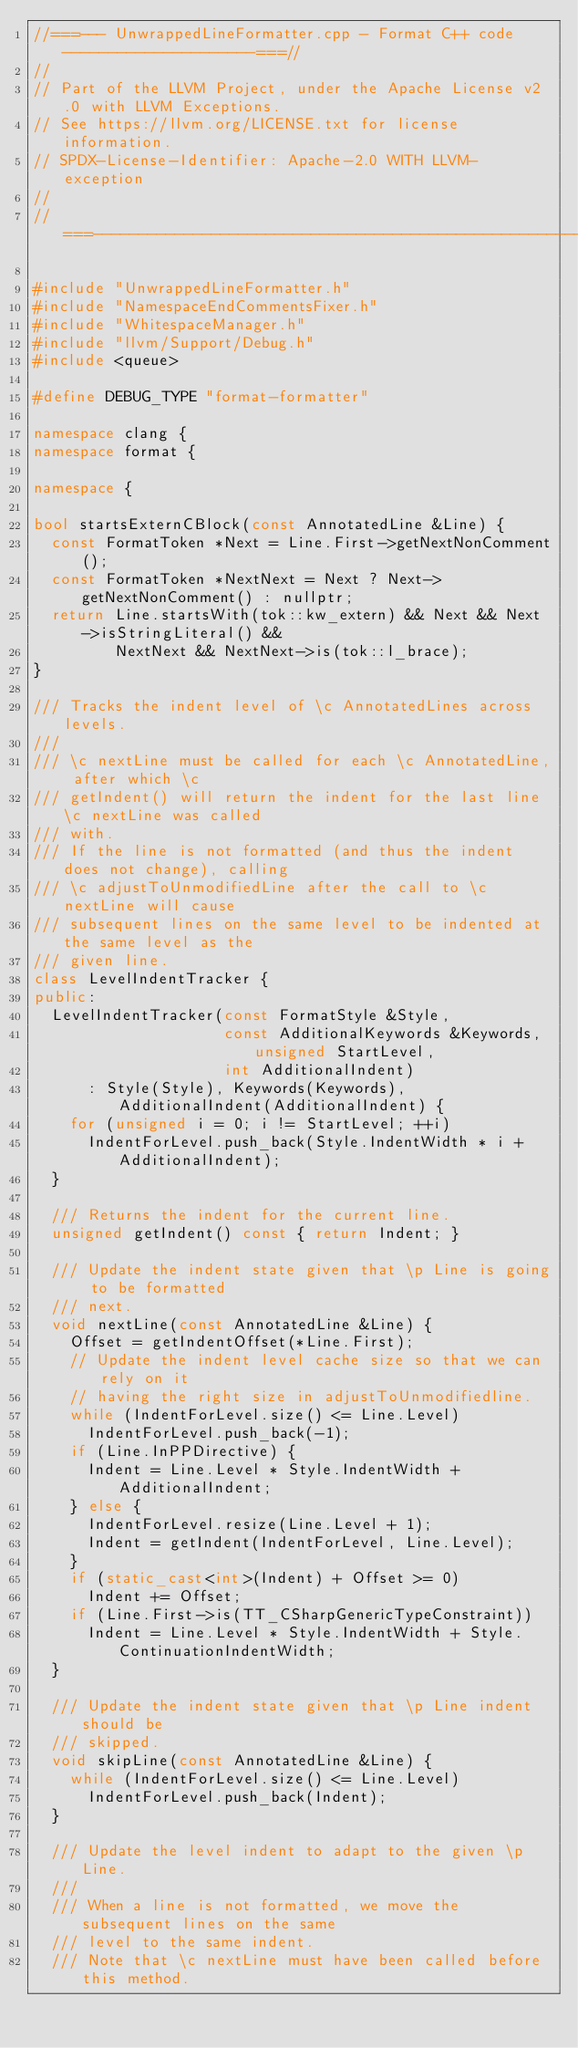<code> <loc_0><loc_0><loc_500><loc_500><_C++_>//===--- UnwrappedLineFormatter.cpp - Format C++ code ---------------------===//
//
// Part of the LLVM Project, under the Apache License v2.0 with LLVM Exceptions.
// See https://llvm.org/LICENSE.txt for license information.
// SPDX-License-Identifier: Apache-2.0 WITH LLVM-exception
//
//===----------------------------------------------------------------------===//

#include "UnwrappedLineFormatter.h"
#include "NamespaceEndCommentsFixer.h"
#include "WhitespaceManager.h"
#include "llvm/Support/Debug.h"
#include <queue>

#define DEBUG_TYPE "format-formatter"

namespace clang {
namespace format {

namespace {

bool startsExternCBlock(const AnnotatedLine &Line) {
  const FormatToken *Next = Line.First->getNextNonComment();
  const FormatToken *NextNext = Next ? Next->getNextNonComment() : nullptr;
  return Line.startsWith(tok::kw_extern) && Next && Next->isStringLiteral() &&
         NextNext && NextNext->is(tok::l_brace);
}

/// Tracks the indent level of \c AnnotatedLines across levels.
///
/// \c nextLine must be called for each \c AnnotatedLine, after which \c
/// getIndent() will return the indent for the last line \c nextLine was called
/// with.
/// If the line is not formatted (and thus the indent does not change), calling
/// \c adjustToUnmodifiedLine after the call to \c nextLine will cause
/// subsequent lines on the same level to be indented at the same level as the
/// given line.
class LevelIndentTracker {
public:
  LevelIndentTracker(const FormatStyle &Style,
                     const AdditionalKeywords &Keywords, unsigned StartLevel,
                     int AdditionalIndent)
      : Style(Style), Keywords(Keywords), AdditionalIndent(AdditionalIndent) {
    for (unsigned i = 0; i != StartLevel; ++i)
      IndentForLevel.push_back(Style.IndentWidth * i + AdditionalIndent);
  }

  /// Returns the indent for the current line.
  unsigned getIndent() const { return Indent; }

  /// Update the indent state given that \p Line is going to be formatted
  /// next.
  void nextLine(const AnnotatedLine &Line) {
    Offset = getIndentOffset(*Line.First);
    // Update the indent level cache size so that we can rely on it
    // having the right size in adjustToUnmodifiedline.
    while (IndentForLevel.size() <= Line.Level)
      IndentForLevel.push_back(-1);
    if (Line.InPPDirective) {
      Indent = Line.Level * Style.IndentWidth + AdditionalIndent;
    } else {
      IndentForLevel.resize(Line.Level + 1);
      Indent = getIndent(IndentForLevel, Line.Level);
    }
    if (static_cast<int>(Indent) + Offset >= 0)
      Indent += Offset;
    if (Line.First->is(TT_CSharpGenericTypeConstraint))
      Indent = Line.Level * Style.IndentWidth + Style.ContinuationIndentWidth;
  }

  /// Update the indent state given that \p Line indent should be
  /// skipped.
  void skipLine(const AnnotatedLine &Line) {
    while (IndentForLevel.size() <= Line.Level)
      IndentForLevel.push_back(Indent);
  }

  /// Update the level indent to adapt to the given \p Line.
  ///
  /// When a line is not formatted, we move the subsequent lines on the same
  /// level to the same indent.
  /// Note that \c nextLine must have been called before this method.</code> 